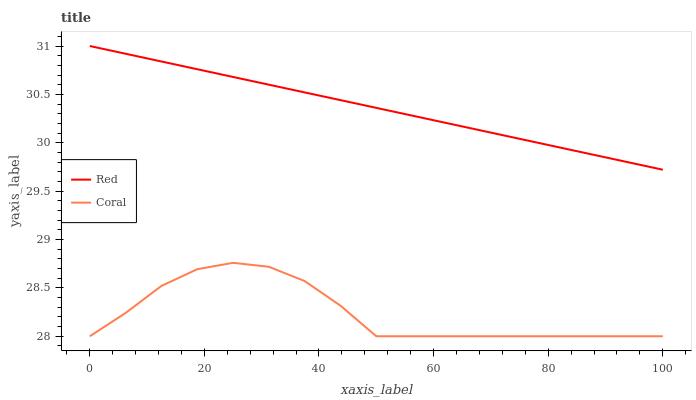Does Coral have the minimum area under the curve?
Answer yes or no. Yes. Does Red have the maximum area under the curve?
Answer yes or no. Yes. Does Red have the minimum area under the curve?
Answer yes or no. No. Is Red the smoothest?
Answer yes or no. Yes. Is Coral the roughest?
Answer yes or no. Yes. Is Red the roughest?
Answer yes or no. No. Does Coral have the lowest value?
Answer yes or no. Yes. Does Red have the lowest value?
Answer yes or no. No. Does Red have the highest value?
Answer yes or no. Yes. Is Coral less than Red?
Answer yes or no. Yes. Is Red greater than Coral?
Answer yes or no. Yes. Does Coral intersect Red?
Answer yes or no. No. 